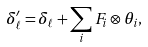<formula> <loc_0><loc_0><loc_500><loc_500>\delta _ { \ell } ^ { \prime } = \delta _ { \ell } + \sum _ { i } F _ { i } \otimes \theta _ { i } ,</formula> 